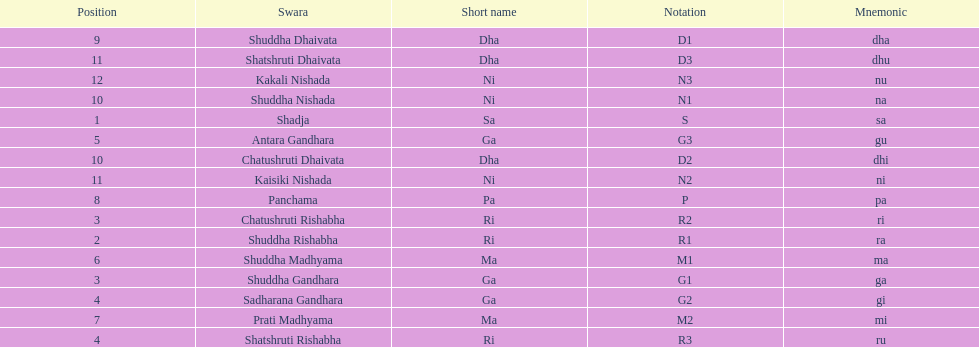Other than m1 how many notations have "1" in them? 4. 